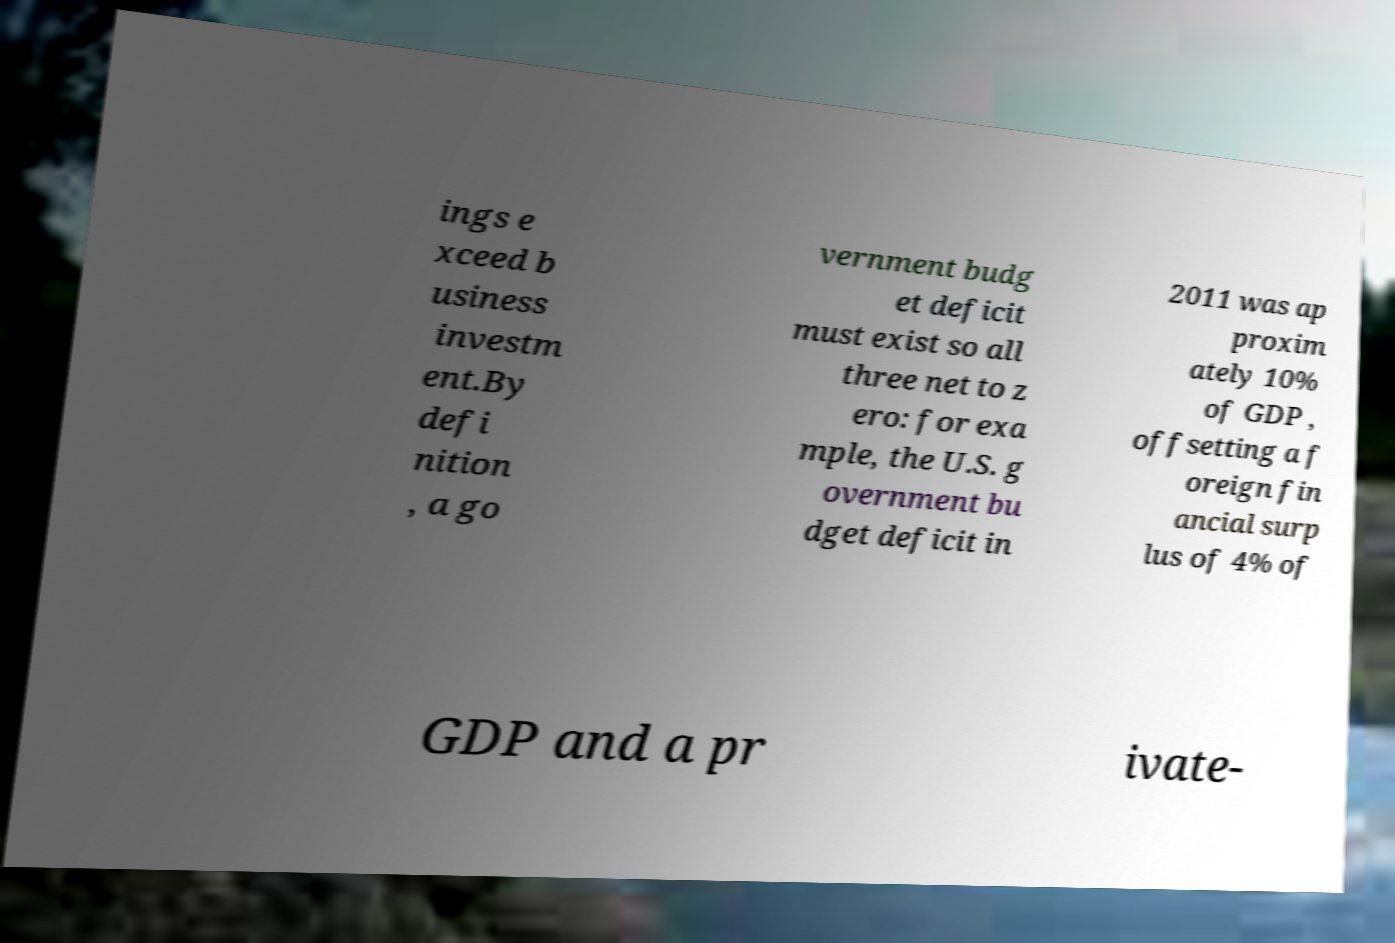Can you accurately transcribe the text from the provided image for me? ings e xceed b usiness investm ent.By defi nition , a go vernment budg et deficit must exist so all three net to z ero: for exa mple, the U.S. g overnment bu dget deficit in 2011 was ap proxim ately 10% of GDP , offsetting a f oreign fin ancial surp lus of 4% of GDP and a pr ivate- 